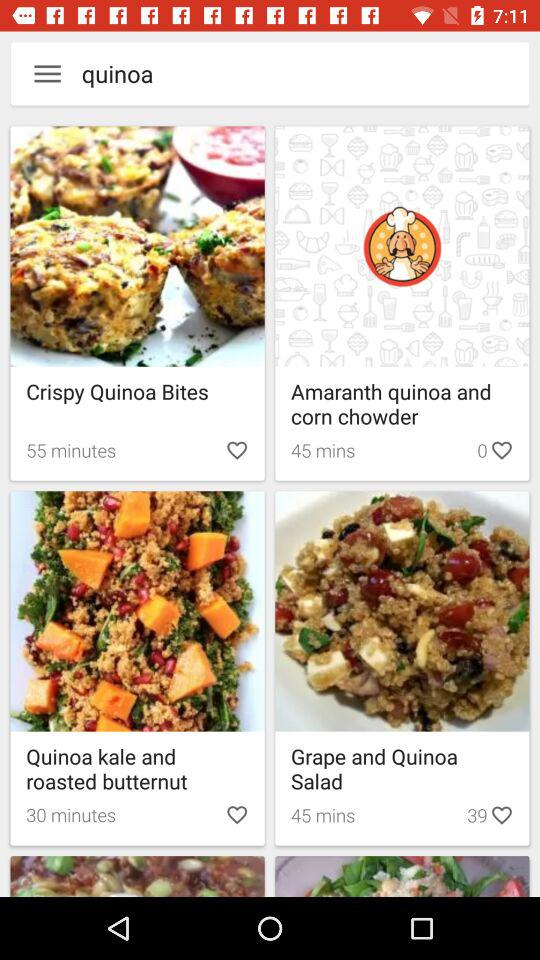How much time is required to make Crispy quinoa bites?
When the provided information is insufficient, respond with <no answer>. <no answer> 